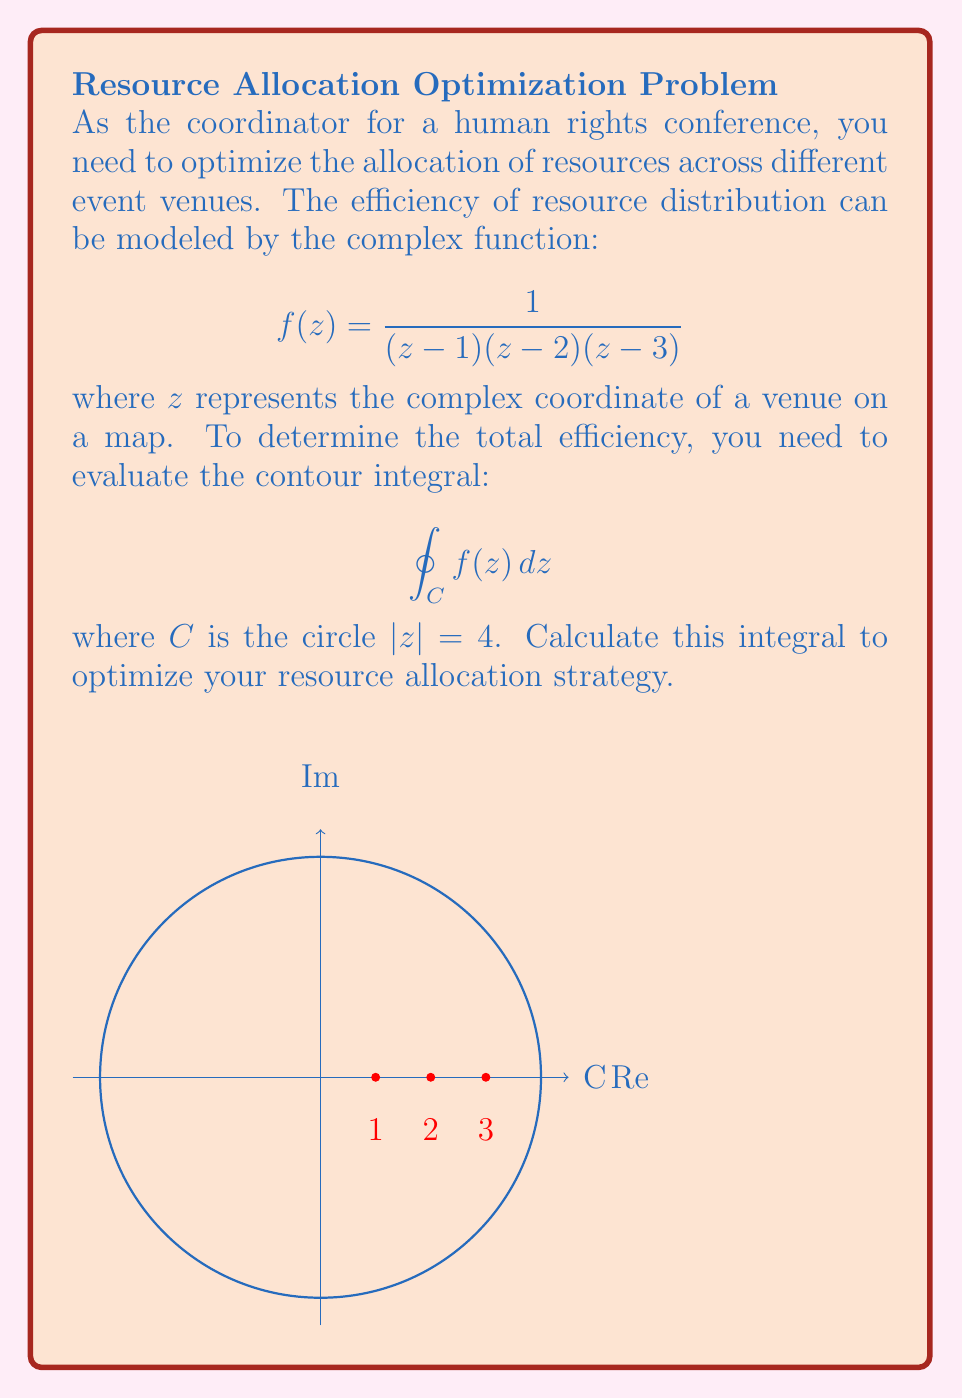Could you help me with this problem? To solve this problem, we'll use the Residue Theorem:

$$\oint_C f(z) dz = 2\pi i \sum_{k=1}^n \text{Res}(f, a_k)$$

where $a_k$ are the poles of $f(z)$ inside $C$.

Step 1: Identify the poles
The poles of $f(z)$ are at $z=1$, $z=2$, and $z=3$, all of which are inside $C$.

Step 2: Calculate residues
For each pole, we calculate the residue:

$\text{Res}(f, 1) = \lim_{z \to 1} (z-1)f(z) = \lim_{z \to 1} \frac{1}{(z-2)(z-3)} = -\frac{1}{2}$

$\text{Res}(f, 2) = \lim_{z \to 2} (z-2)f(z) = \lim_{z \to 2} \frac{1}{(z-1)(z-3)} = \frac{1}{2}$

$\text{Res}(f, 3) = \lim_{z \to 3} (z-3)f(z) = \lim_{z \to 3} \frac{1}{(z-1)(z-2)} = -\frac{1}{6}$

Step 3: Apply the Residue Theorem
$$\oint_C f(z) dz = 2\pi i \left(-\frac{1}{2} + \frac{1}{2} - \frac{1}{6}\right) = 2\pi i \left(-\frac{1}{6}\right) = -\frac{\pi i}{3}$$

The negative imaginary result indicates a clockwise orientation for optimal resource distribution.
Answer: $-\frac{\pi i}{3}$ 